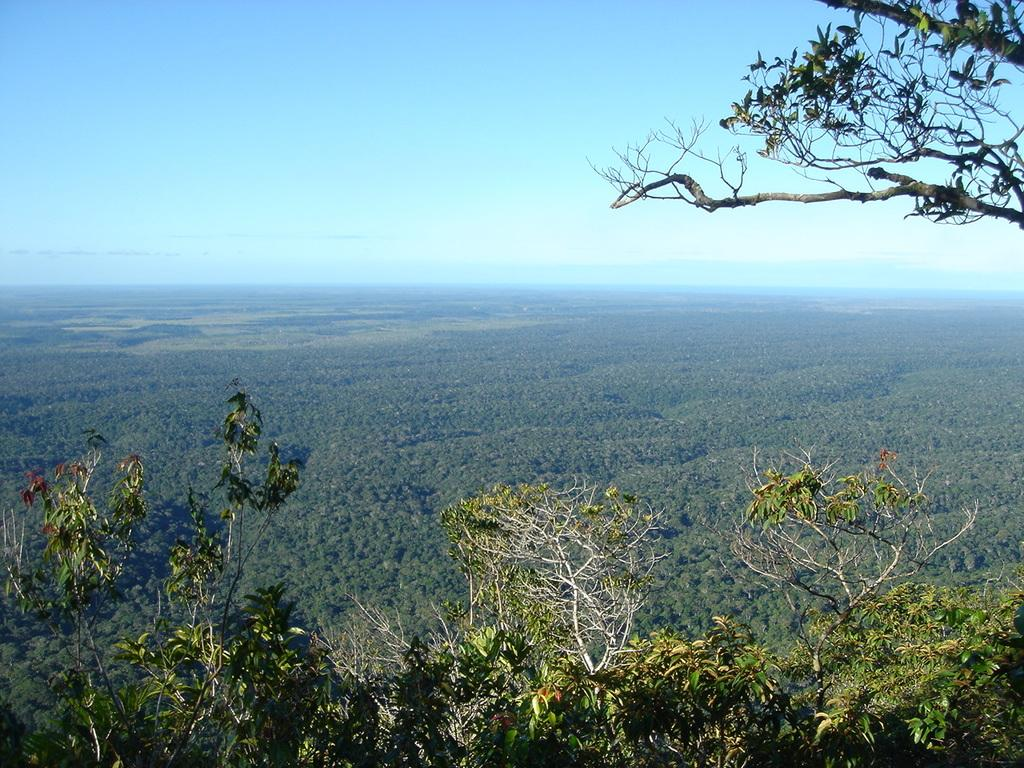What is located in the foreground of the image? There are plants in the foreground of the image. Where is the tree located in the image? There is a tree in the top right corner of the image. What type of vegetation can be seen in the background of the image? There is greenery in the background of the image. What is visible in the background of the image besides the greenery? The sky is visible in the background of the image. Can you describe the sky in the image? There is a cloud in the sky. How does the creature interact with the plants in the image? There is no creature present in the image; it only features plants, a tree, greenery, and a cloudy sky. 